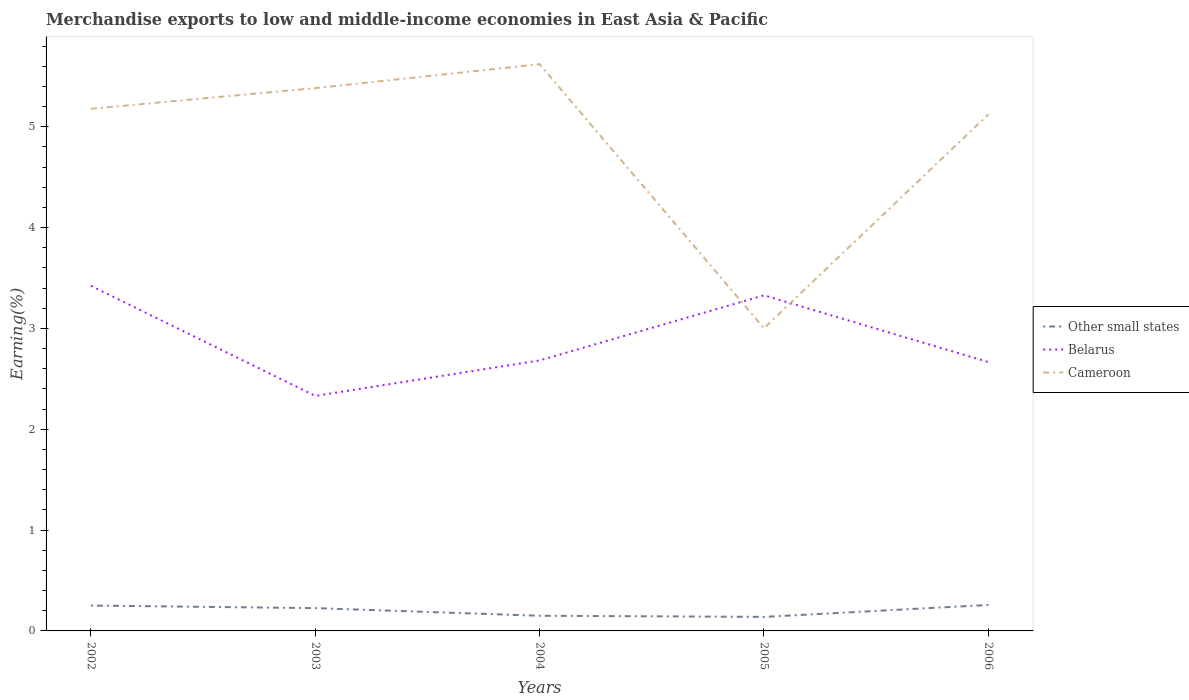How many different coloured lines are there?
Provide a short and direct response. 3. Across all years, what is the maximum percentage of amount earned from merchandise exports in Cameroon?
Offer a terse response. 3. In which year was the percentage of amount earned from merchandise exports in Cameroon maximum?
Give a very brief answer. 2005. What is the total percentage of amount earned from merchandise exports in Other small states in the graph?
Provide a succinct answer. 0.09. What is the difference between the highest and the second highest percentage of amount earned from merchandise exports in Belarus?
Your response must be concise. 1.09. What is the difference between the highest and the lowest percentage of amount earned from merchandise exports in Cameroon?
Give a very brief answer. 4. Is the percentage of amount earned from merchandise exports in Belarus strictly greater than the percentage of amount earned from merchandise exports in Cameroon over the years?
Provide a succinct answer. No. How many lines are there?
Keep it short and to the point. 3. How many years are there in the graph?
Provide a succinct answer. 5. What is the difference between two consecutive major ticks on the Y-axis?
Ensure brevity in your answer.  1. Does the graph contain grids?
Provide a succinct answer. No. Where does the legend appear in the graph?
Ensure brevity in your answer.  Center right. How many legend labels are there?
Keep it short and to the point. 3. What is the title of the graph?
Your response must be concise. Merchandise exports to low and middle-income economies in East Asia & Pacific. Does "Equatorial Guinea" appear as one of the legend labels in the graph?
Make the answer very short. No. What is the label or title of the X-axis?
Offer a terse response. Years. What is the label or title of the Y-axis?
Offer a terse response. Earning(%). What is the Earning(%) of Other small states in 2002?
Keep it short and to the point. 0.25. What is the Earning(%) of Belarus in 2002?
Your response must be concise. 3.42. What is the Earning(%) of Cameroon in 2002?
Keep it short and to the point. 5.18. What is the Earning(%) of Other small states in 2003?
Ensure brevity in your answer.  0.23. What is the Earning(%) in Belarus in 2003?
Keep it short and to the point. 2.33. What is the Earning(%) in Cameroon in 2003?
Provide a short and direct response. 5.38. What is the Earning(%) in Other small states in 2004?
Give a very brief answer. 0.15. What is the Earning(%) in Belarus in 2004?
Your answer should be compact. 2.68. What is the Earning(%) in Cameroon in 2004?
Your response must be concise. 5.62. What is the Earning(%) in Other small states in 2005?
Provide a succinct answer. 0.14. What is the Earning(%) of Belarus in 2005?
Keep it short and to the point. 3.33. What is the Earning(%) in Cameroon in 2005?
Make the answer very short. 3. What is the Earning(%) in Other small states in 2006?
Your answer should be compact. 0.26. What is the Earning(%) of Belarus in 2006?
Make the answer very short. 2.67. What is the Earning(%) in Cameroon in 2006?
Offer a very short reply. 5.12. Across all years, what is the maximum Earning(%) in Other small states?
Provide a short and direct response. 0.26. Across all years, what is the maximum Earning(%) in Belarus?
Keep it short and to the point. 3.42. Across all years, what is the maximum Earning(%) in Cameroon?
Offer a terse response. 5.62. Across all years, what is the minimum Earning(%) of Other small states?
Ensure brevity in your answer.  0.14. Across all years, what is the minimum Earning(%) in Belarus?
Provide a succinct answer. 2.33. Across all years, what is the minimum Earning(%) in Cameroon?
Give a very brief answer. 3. What is the total Earning(%) in Other small states in the graph?
Provide a succinct answer. 1.03. What is the total Earning(%) of Belarus in the graph?
Offer a very short reply. 14.43. What is the total Earning(%) in Cameroon in the graph?
Your response must be concise. 24.31. What is the difference between the Earning(%) of Other small states in 2002 and that in 2003?
Offer a terse response. 0.03. What is the difference between the Earning(%) of Belarus in 2002 and that in 2003?
Your answer should be very brief. 1.09. What is the difference between the Earning(%) in Cameroon in 2002 and that in 2003?
Make the answer very short. -0.21. What is the difference between the Earning(%) of Other small states in 2002 and that in 2004?
Your response must be concise. 0.1. What is the difference between the Earning(%) in Belarus in 2002 and that in 2004?
Your answer should be compact. 0.74. What is the difference between the Earning(%) of Cameroon in 2002 and that in 2004?
Provide a short and direct response. -0.44. What is the difference between the Earning(%) in Other small states in 2002 and that in 2005?
Give a very brief answer. 0.11. What is the difference between the Earning(%) of Belarus in 2002 and that in 2005?
Keep it short and to the point. 0.09. What is the difference between the Earning(%) of Cameroon in 2002 and that in 2005?
Make the answer very short. 2.18. What is the difference between the Earning(%) in Other small states in 2002 and that in 2006?
Give a very brief answer. -0.01. What is the difference between the Earning(%) in Belarus in 2002 and that in 2006?
Your answer should be very brief. 0.76. What is the difference between the Earning(%) of Cameroon in 2002 and that in 2006?
Make the answer very short. 0.06. What is the difference between the Earning(%) of Other small states in 2003 and that in 2004?
Ensure brevity in your answer.  0.08. What is the difference between the Earning(%) of Belarus in 2003 and that in 2004?
Your response must be concise. -0.35. What is the difference between the Earning(%) in Cameroon in 2003 and that in 2004?
Your answer should be very brief. -0.24. What is the difference between the Earning(%) in Other small states in 2003 and that in 2005?
Provide a succinct answer. 0.09. What is the difference between the Earning(%) in Belarus in 2003 and that in 2005?
Your answer should be very brief. -1. What is the difference between the Earning(%) in Cameroon in 2003 and that in 2005?
Offer a very short reply. 2.38. What is the difference between the Earning(%) in Other small states in 2003 and that in 2006?
Give a very brief answer. -0.03. What is the difference between the Earning(%) of Belarus in 2003 and that in 2006?
Your answer should be compact. -0.34. What is the difference between the Earning(%) of Cameroon in 2003 and that in 2006?
Offer a terse response. 0.26. What is the difference between the Earning(%) of Other small states in 2004 and that in 2005?
Offer a very short reply. 0.01. What is the difference between the Earning(%) in Belarus in 2004 and that in 2005?
Offer a terse response. -0.65. What is the difference between the Earning(%) in Cameroon in 2004 and that in 2005?
Your answer should be very brief. 2.62. What is the difference between the Earning(%) in Other small states in 2004 and that in 2006?
Offer a terse response. -0.11. What is the difference between the Earning(%) of Belarus in 2004 and that in 2006?
Your response must be concise. 0.02. What is the difference between the Earning(%) of Cameroon in 2004 and that in 2006?
Your answer should be compact. 0.5. What is the difference between the Earning(%) in Other small states in 2005 and that in 2006?
Provide a succinct answer. -0.12. What is the difference between the Earning(%) in Belarus in 2005 and that in 2006?
Offer a terse response. 0.66. What is the difference between the Earning(%) of Cameroon in 2005 and that in 2006?
Provide a short and direct response. -2.12. What is the difference between the Earning(%) of Other small states in 2002 and the Earning(%) of Belarus in 2003?
Ensure brevity in your answer.  -2.08. What is the difference between the Earning(%) in Other small states in 2002 and the Earning(%) in Cameroon in 2003?
Your response must be concise. -5.13. What is the difference between the Earning(%) in Belarus in 2002 and the Earning(%) in Cameroon in 2003?
Your answer should be very brief. -1.96. What is the difference between the Earning(%) in Other small states in 2002 and the Earning(%) in Belarus in 2004?
Your answer should be very brief. -2.43. What is the difference between the Earning(%) in Other small states in 2002 and the Earning(%) in Cameroon in 2004?
Your answer should be compact. -5.37. What is the difference between the Earning(%) of Belarus in 2002 and the Earning(%) of Cameroon in 2004?
Ensure brevity in your answer.  -2.2. What is the difference between the Earning(%) in Other small states in 2002 and the Earning(%) in Belarus in 2005?
Give a very brief answer. -3.08. What is the difference between the Earning(%) in Other small states in 2002 and the Earning(%) in Cameroon in 2005?
Make the answer very short. -2.75. What is the difference between the Earning(%) in Belarus in 2002 and the Earning(%) in Cameroon in 2005?
Offer a very short reply. 0.42. What is the difference between the Earning(%) in Other small states in 2002 and the Earning(%) in Belarus in 2006?
Your answer should be very brief. -2.42. What is the difference between the Earning(%) of Other small states in 2002 and the Earning(%) of Cameroon in 2006?
Keep it short and to the point. -4.87. What is the difference between the Earning(%) in Belarus in 2002 and the Earning(%) in Cameroon in 2006?
Give a very brief answer. -1.7. What is the difference between the Earning(%) of Other small states in 2003 and the Earning(%) of Belarus in 2004?
Make the answer very short. -2.46. What is the difference between the Earning(%) in Other small states in 2003 and the Earning(%) in Cameroon in 2004?
Make the answer very short. -5.39. What is the difference between the Earning(%) of Belarus in 2003 and the Earning(%) of Cameroon in 2004?
Provide a short and direct response. -3.29. What is the difference between the Earning(%) of Other small states in 2003 and the Earning(%) of Belarus in 2005?
Your answer should be compact. -3.1. What is the difference between the Earning(%) of Other small states in 2003 and the Earning(%) of Cameroon in 2005?
Your response must be concise. -2.78. What is the difference between the Earning(%) of Belarus in 2003 and the Earning(%) of Cameroon in 2005?
Keep it short and to the point. -0.67. What is the difference between the Earning(%) of Other small states in 2003 and the Earning(%) of Belarus in 2006?
Your answer should be compact. -2.44. What is the difference between the Earning(%) of Other small states in 2003 and the Earning(%) of Cameroon in 2006?
Ensure brevity in your answer.  -4.9. What is the difference between the Earning(%) in Belarus in 2003 and the Earning(%) in Cameroon in 2006?
Give a very brief answer. -2.79. What is the difference between the Earning(%) of Other small states in 2004 and the Earning(%) of Belarus in 2005?
Give a very brief answer. -3.18. What is the difference between the Earning(%) in Other small states in 2004 and the Earning(%) in Cameroon in 2005?
Offer a very short reply. -2.85. What is the difference between the Earning(%) in Belarus in 2004 and the Earning(%) in Cameroon in 2005?
Ensure brevity in your answer.  -0.32. What is the difference between the Earning(%) of Other small states in 2004 and the Earning(%) of Belarus in 2006?
Your answer should be compact. -2.52. What is the difference between the Earning(%) in Other small states in 2004 and the Earning(%) in Cameroon in 2006?
Make the answer very short. -4.97. What is the difference between the Earning(%) of Belarus in 2004 and the Earning(%) of Cameroon in 2006?
Ensure brevity in your answer.  -2.44. What is the difference between the Earning(%) of Other small states in 2005 and the Earning(%) of Belarus in 2006?
Your answer should be very brief. -2.53. What is the difference between the Earning(%) in Other small states in 2005 and the Earning(%) in Cameroon in 2006?
Offer a terse response. -4.98. What is the difference between the Earning(%) in Belarus in 2005 and the Earning(%) in Cameroon in 2006?
Provide a succinct answer. -1.79. What is the average Earning(%) of Other small states per year?
Your response must be concise. 0.2. What is the average Earning(%) in Belarus per year?
Provide a succinct answer. 2.89. What is the average Earning(%) of Cameroon per year?
Provide a short and direct response. 4.86. In the year 2002, what is the difference between the Earning(%) in Other small states and Earning(%) in Belarus?
Provide a succinct answer. -3.17. In the year 2002, what is the difference between the Earning(%) of Other small states and Earning(%) of Cameroon?
Provide a succinct answer. -4.93. In the year 2002, what is the difference between the Earning(%) in Belarus and Earning(%) in Cameroon?
Provide a short and direct response. -1.76. In the year 2003, what is the difference between the Earning(%) in Other small states and Earning(%) in Belarus?
Make the answer very short. -2.1. In the year 2003, what is the difference between the Earning(%) in Other small states and Earning(%) in Cameroon?
Provide a short and direct response. -5.16. In the year 2003, what is the difference between the Earning(%) in Belarus and Earning(%) in Cameroon?
Your response must be concise. -3.05. In the year 2004, what is the difference between the Earning(%) in Other small states and Earning(%) in Belarus?
Keep it short and to the point. -2.53. In the year 2004, what is the difference between the Earning(%) of Other small states and Earning(%) of Cameroon?
Offer a terse response. -5.47. In the year 2004, what is the difference between the Earning(%) in Belarus and Earning(%) in Cameroon?
Your response must be concise. -2.94. In the year 2005, what is the difference between the Earning(%) in Other small states and Earning(%) in Belarus?
Provide a succinct answer. -3.19. In the year 2005, what is the difference between the Earning(%) in Other small states and Earning(%) in Cameroon?
Provide a short and direct response. -2.86. In the year 2005, what is the difference between the Earning(%) in Belarus and Earning(%) in Cameroon?
Give a very brief answer. 0.33. In the year 2006, what is the difference between the Earning(%) of Other small states and Earning(%) of Belarus?
Provide a short and direct response. -2.41. In the year 2006, what is the difference between the Earning(%) of Other small states and Earning(%) of Cameroon?
Your answer should be very brief. -4.87. In the year 2006, what is the difference between the Earning(%) of Belarus and Earning(%) of Cameroon?
Provide a short and direct response. -2.46. What is the ratio of the Earning(%) in Other small states in 2002 to that in 2003?
Your answer should be very brief. 1.11. What is the ratio of the Earning(%) of Belarus in 2002 to that in 2003?
Your answer should be very brief. 1.47. What is the ratio of the Earning(%) of Cameroon in 2002 to that in 2003?
Your response must be concise. 0.96. What is the ratio of the Earning(%) in Other small states in 2002 to that in 2004?
Your response must be concise. 1.67. What is the ratio of the Earning(%) of Belarus in 2002 to that in 2004?
Ensure brevity in your answer.  1.28. What is the ratio of the Earning(%) in Cameroon in 2002 to that in 2004?
Your answer should be very brief. 0.92. What is the ratio of the Earning(%) in Other small states in 2002 to that in 2005?
Provide a short and direct response. 1.81. What is the ratio of the Earning(%) in Belarus in 2002 to that in 2005?
Offer a terse response. 1.03. What is the ratio of the Earning(%) of Cameroon in 2002 to that in 2005?
Your answer should be very brief. 1.73. What is the ratio of the Earning(%) in Other small states in 2002 to that in 2006?
Your response must be concise. 0.98. What is the ratio of the Earning(%) in Belarus in 2002 to that in 2006?
Ensure brevity in your answer.  1.28. What is the ratio of the Earning(%) in Cameroon in 2002 to that in 2006?
Your response must be concise. 1.01. What is the ratio of the Earning(%) in Other small states in 2003 to that in 2004?
Offer a terse response. 1.5. What is the ratio of the Earning(%) in Belarus in 2003 to that in 2004?
Offer a terse response. 0.87. What is the ratio of the Earning(%) in Cameroon in 2003 to that in 2004?
Your answer should be very brief. 0.96. What is the ratio of the Earning(%) of Other small states in 2003 to that in 2005?
Your response must be concise. 1.63. What is the ratio of the Earning(%) of Belarus in 2003 to that in 2005?
Your answer should be compact. 0.7. What is the ratio of the Earning(%) of Cameroon in 2003 to that in 2005?
Keep it short and to the point. 1.79. What is the ratio of the Earning(%) of Other small states in 2003 to that in 2006?
Provide a short and direct response. 0.88. What is the ratio of the Earning(%) of Belarus in 2003 to that in 2006?
Your response must be concise. 0.87. What is the ratio of the Earning(%) of Cameroon in 2003 to that in 2006?
Your answer should be very brief. 1.05. What is the ratio of the Earning(%) of Other small states in 2004 to that in 2005?
Offer a terse response. 1.08. What is the ratio of the Earning(%) in Belarus in 2004 to that in 2005?
Provide a succinct answer. 0.81. What is the ratio of the Earning(%) in Cameroon in 2004 to that in 2005?
Offer a very short reply. 1.87. What is the ratio of the Earning(%) in Other small states in 2004 to that in 2006?
Provide a succinct answer. 0.58. What is the ratio of the Earning(%) in Belarus in 2004 to that in 2006?
Offer a terse response. 1.01. What is the ratio of the Earning(%) of Cameroon in 2004 to that in 2006?
Keep it short and to the point. 1.1. What is the ratio of the Earning(%) of Other small states in 2005 to that in 2006?
Your answer should be compact. 0.54. What is the ratio of the Earning(%) in Belarus in 2005 to that in 2006?
Give a very brief answer. 1.25. What is the ratio of the Earning(%) of Cameroon in 2005 to that in 2006?
Your answer should be very brief. 0.59. What is the difference between the highest and the second highest Earning(%) of Other small states?
Ensure brevity in your answer.  0.01. What is the difference between the highest and the second highest Earning(%) of Belarus?
Provide a short and direct response. 0.09. What is the difference between the highest and the second highest Earning(%) in Cameroon?
Offer a terse response. 0.24. What is the difference between the highest and the lowest Earning(%) of Other small states?
Your answer should be very brief. 0.12. What is the difference between the highest and the lowest Earning(%) of Belarus?
Your answer should be very brief. 1.09. What is the difference between the highest and the lowest Earning(%) of Cameroon?
Provide a succinct answer. 2.62. 